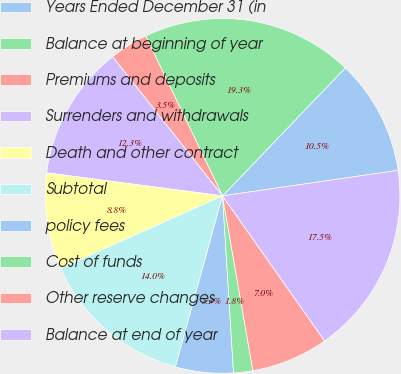Convert chart to OTSL. <chart><loc_0><loc_0><loc_500><loc_500><pie_chart><fcel>Years Ended December 31 (in<fcel>Balance at beginning of year<fcel>Premiums and deposits<fcel>Surrenders and withdrawals<fcel>Death and other contract<fcel>Subtotal<fcel>policy fees<fcel>Cost of funds<fcel>Other reserve changes<fcel>Balance at end of year<nl><fcel>10.53%<fcel>19.3%<fcel>3.51%<fcel>12.28%<fcel>8.77%<fcel>14.03%<fcel>5.26%<fcel>1.75%<fcel>7.02%<fcel>17.54%<nl></chart> 